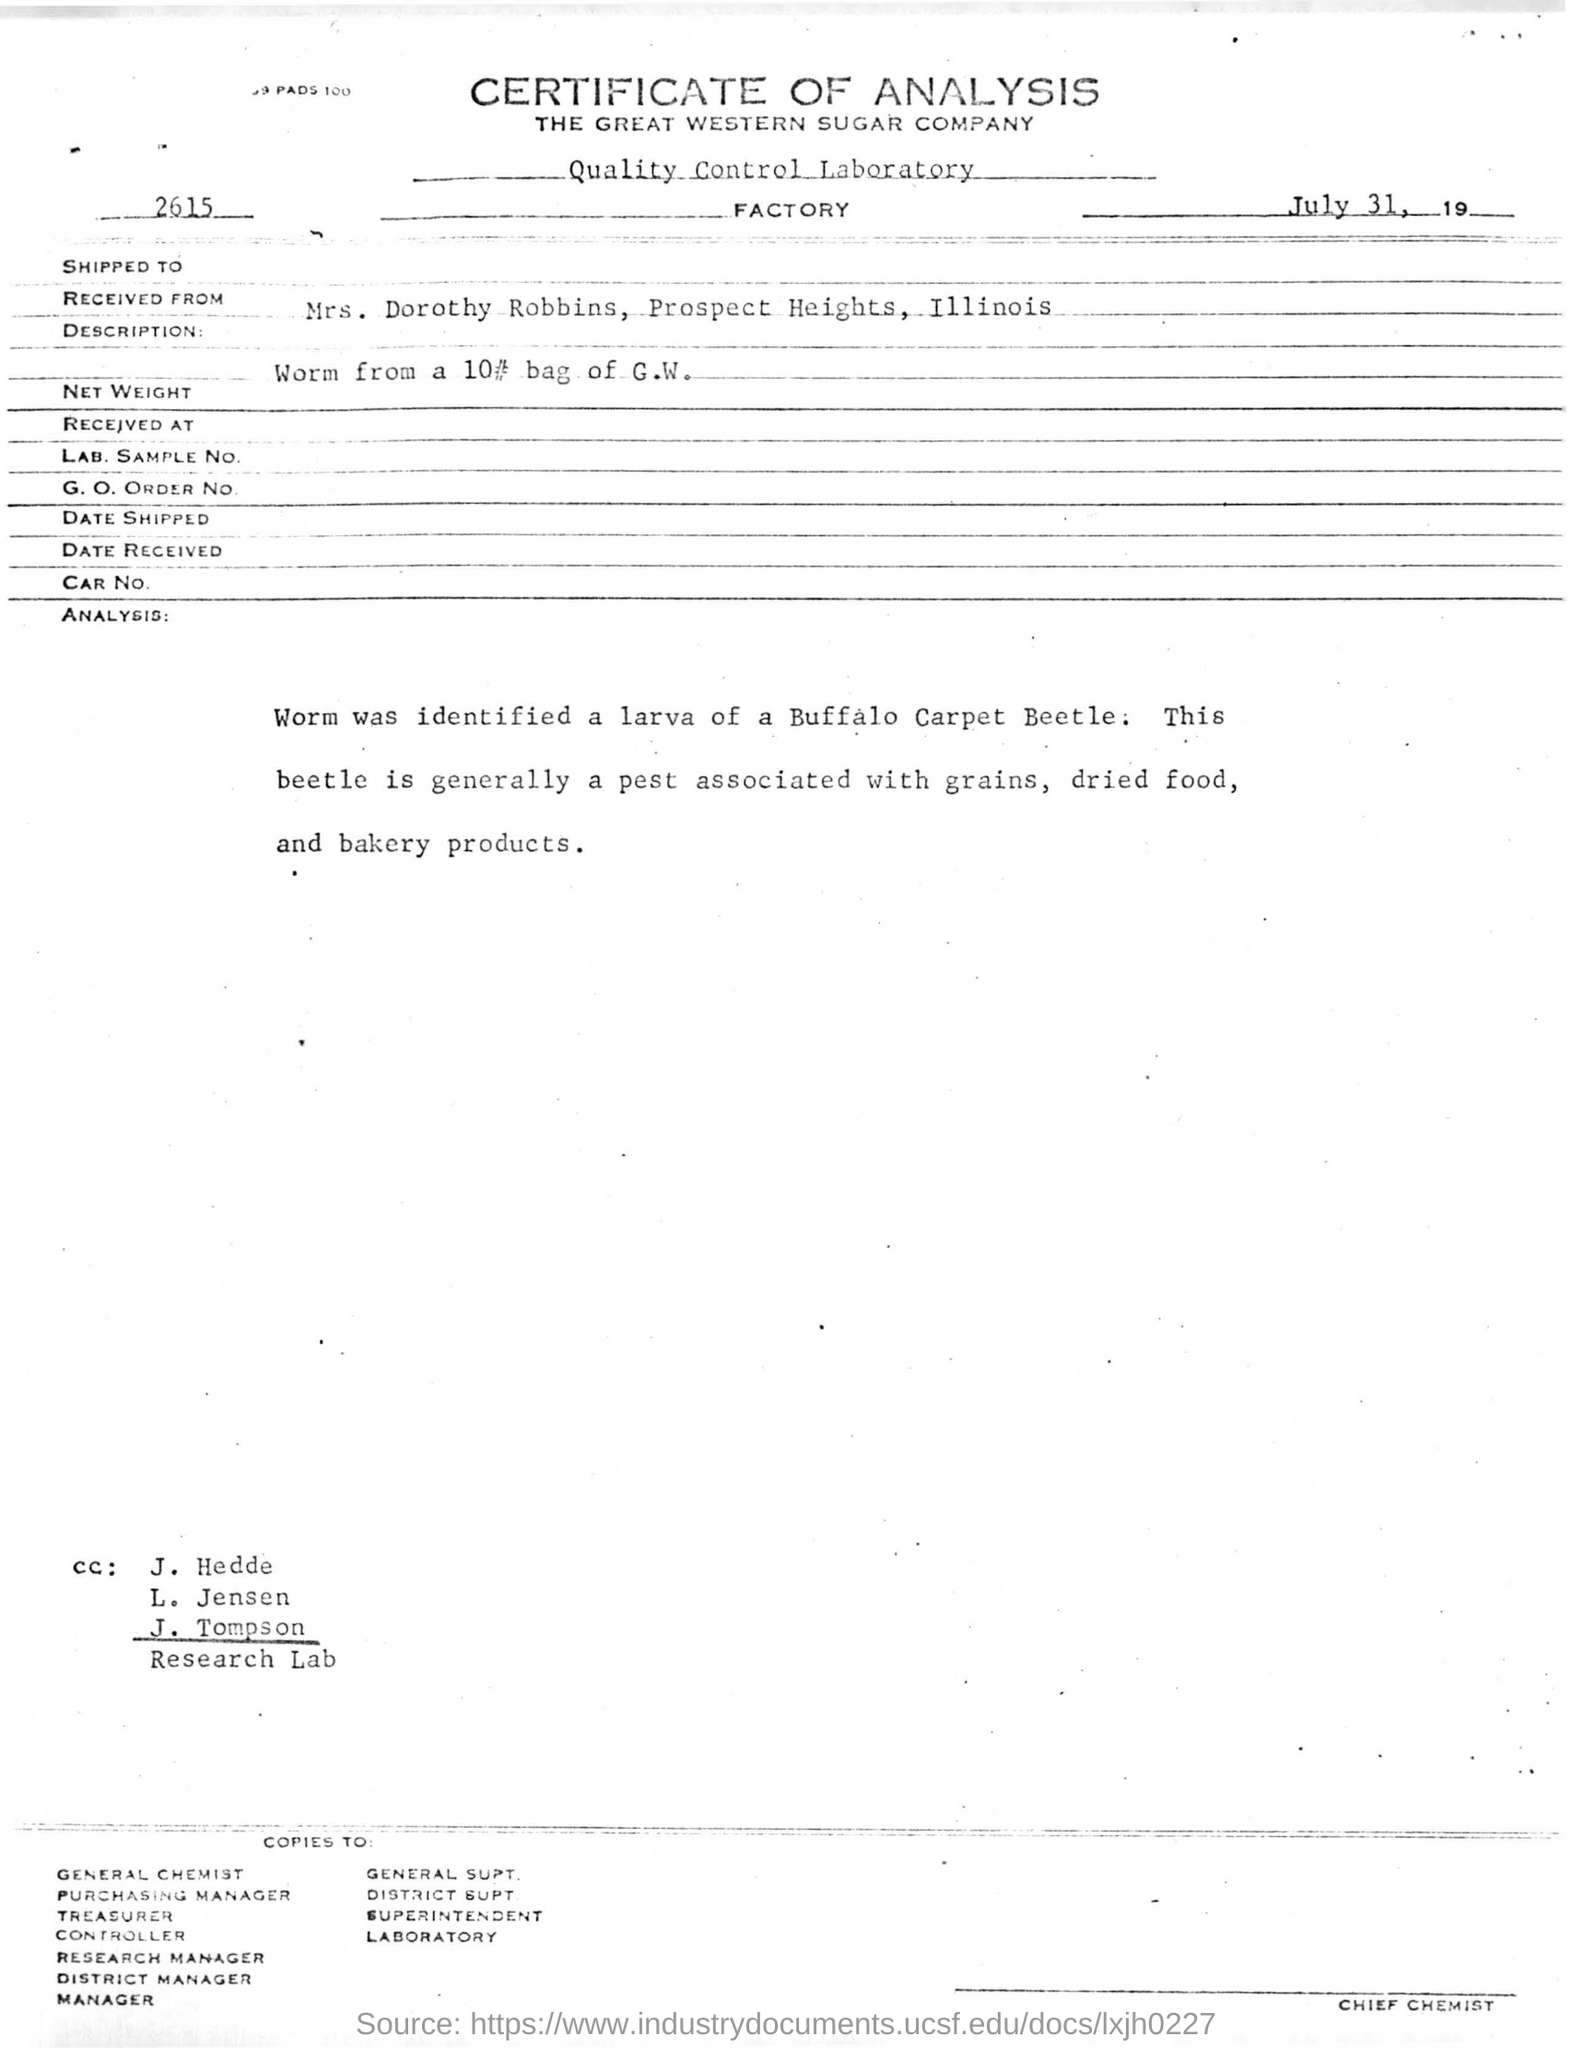Mention a couple of crucial points in this snapshot. The Great Western Sugar Company is mentioned in the letterhead. The identified beetle larva is a Buffalo Carpet Beetle. 